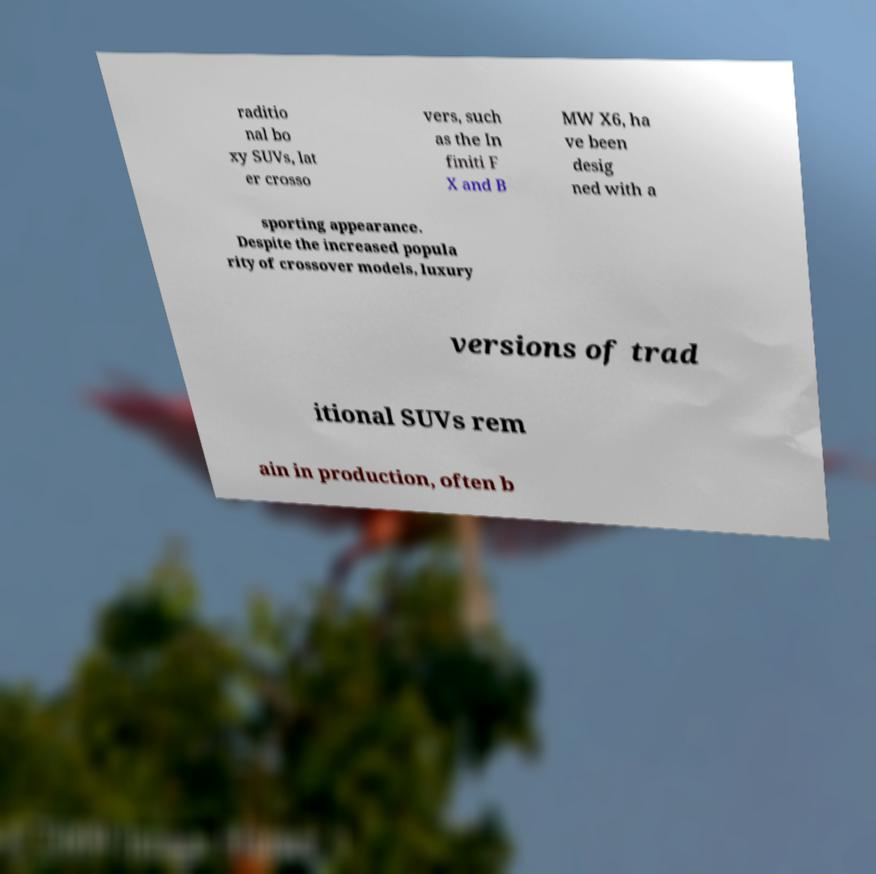Can you read and provide the text displayed in the image?This photo seems to have some interesting text. Can you extract and type it out for me? raditio nal bo xy SUVs, lat er crosso vers, such as the In finiti F X and B MW X6, ha ve been desig ned with a sporting appearance. Despite the increased popula rity of crossover models, luxury versions of trad itional SUVs rem ain in production, often b 